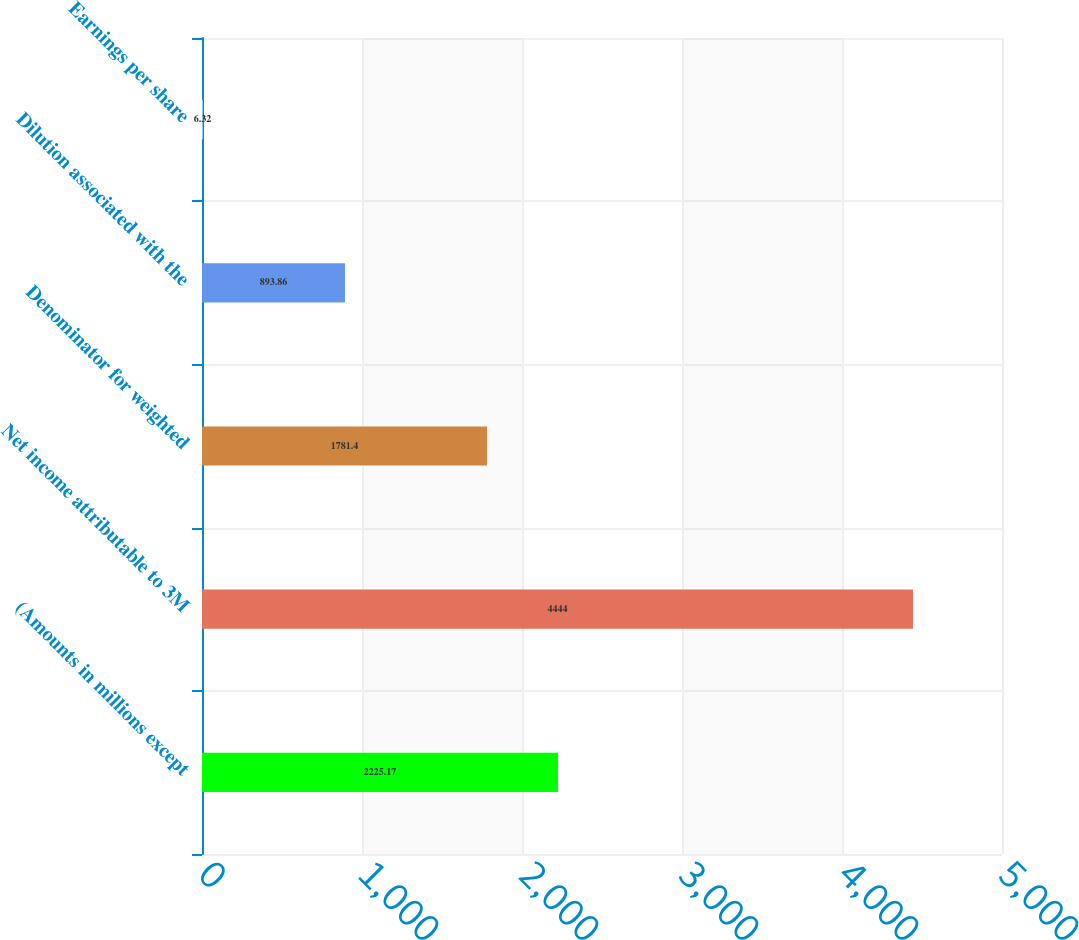Convert chart to OTSL. <chart><loc_0><loc_0><loc_500><loc_500><bar_chart><fcel>(Amounts in millions except<fcel>Net income attributable to 3M<fcel>Denominator for weighted<fcel>Dilution associated with the<fcel>Earnings per share<nl><fcel>2225.17<fcel>4444<fcel>1781.4<fcel>893.86<fcel>6.32<nl></chart> 